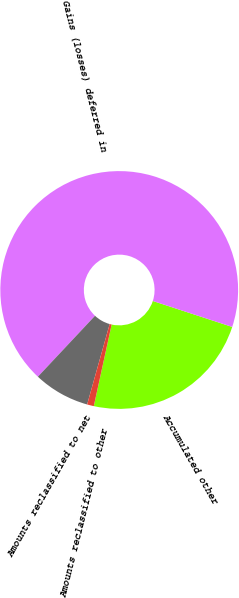<chart> <loc_0><loc_0><loc_500><loc_500><pie_chart><fcel>Accumulated other<fcel>Gains (losses) deferred in<fcel>Amounts reclassified to net<fcel>Amounts reclassified to other<nl><fcel>23.4%<fcel>68.04%<fcel>7.64%<fcel>0.92%<nl></chart> 